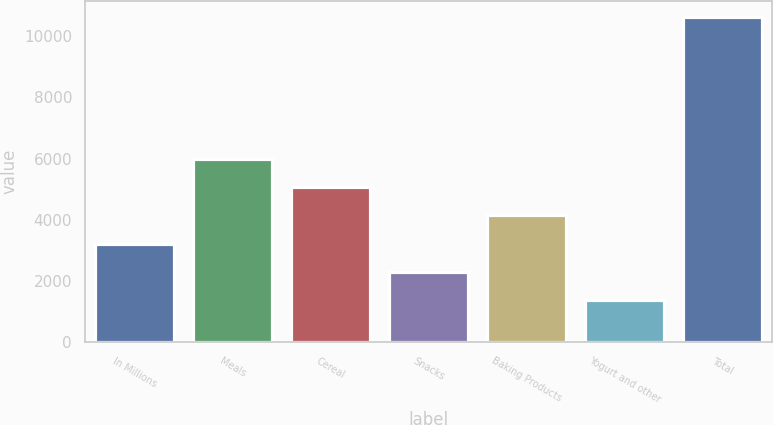Convert chart. <chart><loc_0><loc_0><loc_500><loc_500><bar_chart><fcel>In Millions<fcel>Meals<fcel>Cereal<fcel>Snacks<fcel>Baking Products<fcel>Yogurt and other<fcel>Total<nl><fcel>3218.66<fcel>5992.25<fcel>5067.72<fcel>2294.13<fcel>4143.19<fcel>1369.6<fcel>10614.9<nl></chart> 